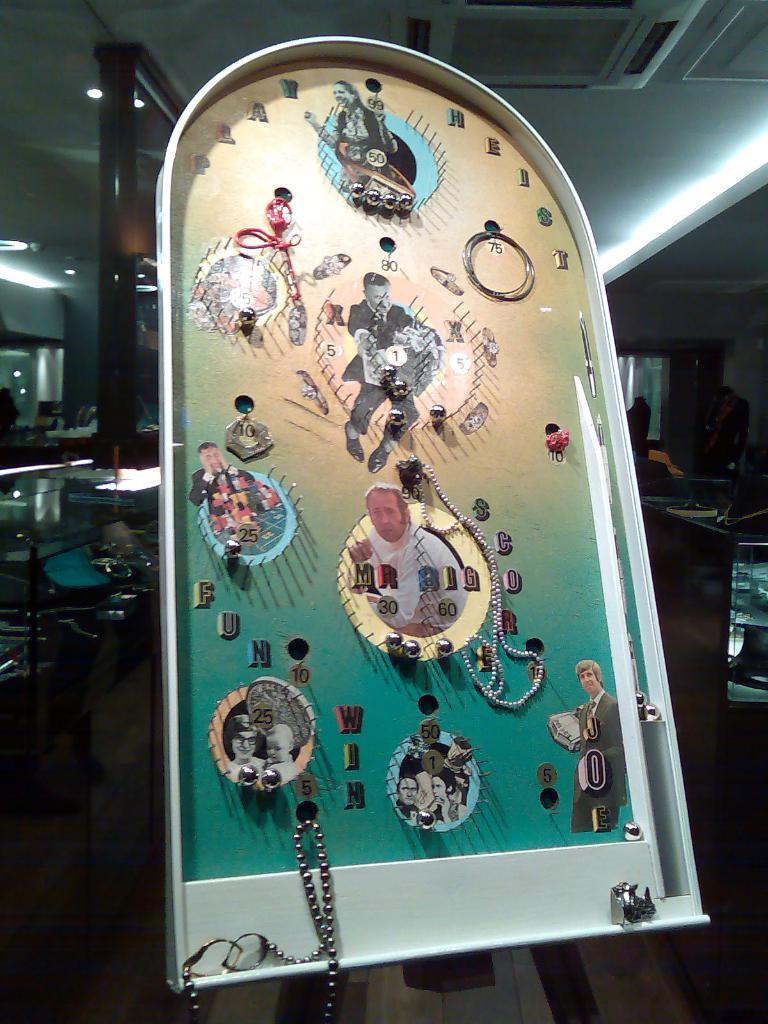Describe this image in one or two sentences. There is a board on which some of the photos and chains were placed on it. In the background we can observe light and something is placed in the dark. 